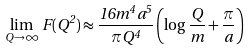Convert formula to latex. <formula><loc_0><loc_0><loc_500><loc_500>\lim _ { Q \to \infty } \, F ( Q ^ { 2 } ) \approx \frac { 1 6 m ^ { 4 } a ^ { 5 } } { \pi Q ^ { 4 } } \left ( \log \frac { Q } { m } + \frac { \pi } { a } \right )</formula> 